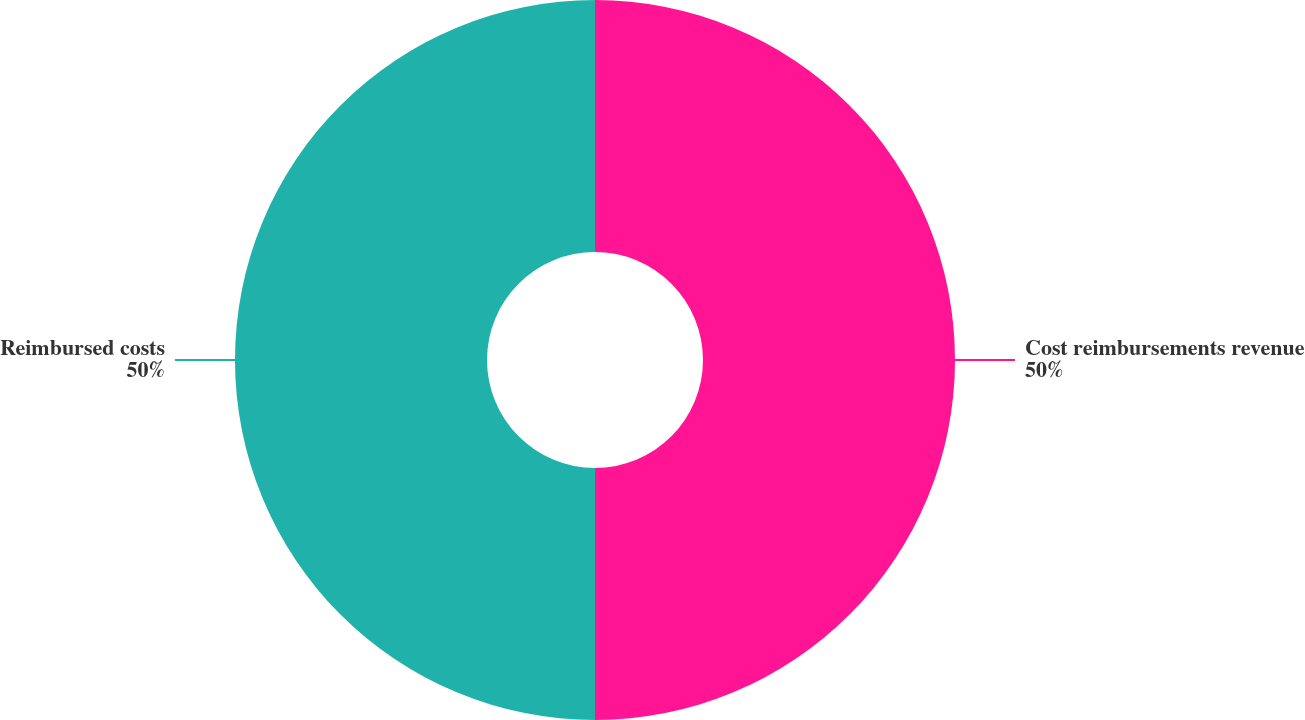Convert chart to OTSL. <chart><loc_0><loc_0><loc_500><loc_500><pie_chart><fcel>Cost reimbursements revenue<fcel>Reimbursed costs<nl><fcel>50.0%<fcel>50.0%<nl></chart> 